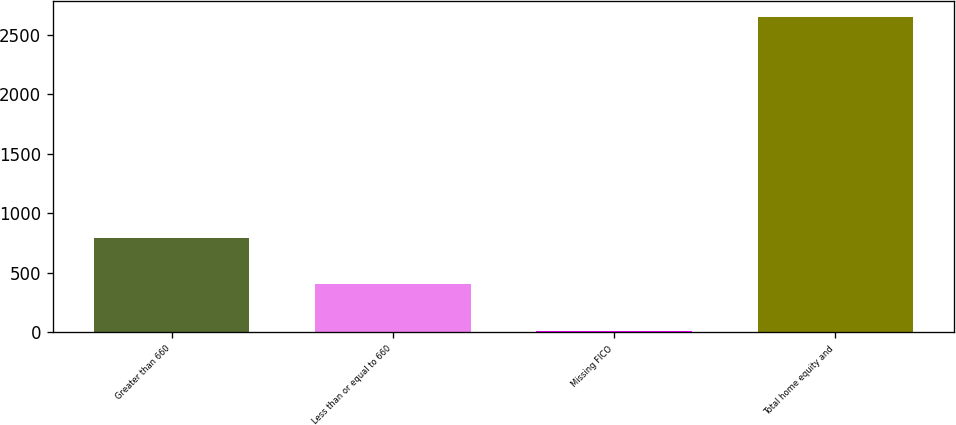Convert chart to OTSL. <chart><loc_0><loc_0><loc_500><loc_500><bar_chart><fcel>Greater than 660<fcel>Less than or equal to 660<fcel>Missing FICO<fcel>Total home equity and<nl><fcel>791<fcel>405<fcel>8<fcel>2649<nl></chart> 